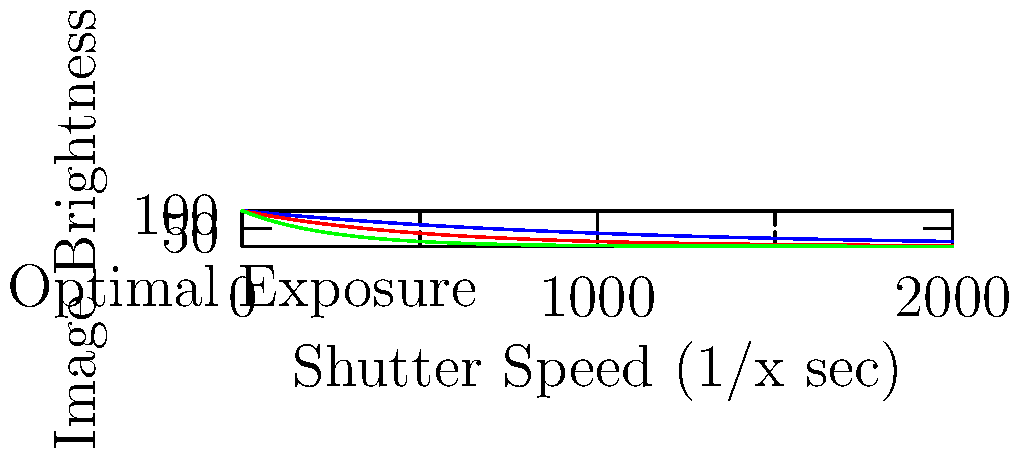You're shooting a dimly lit indoor basketball game. Given the graph showing the relationship between shutter speed and image brightness for different ISO settings, which combination of settings would you choose to achieve optimal exposure while minimizing motion blur?

A) 1/500 sec, ISO 1600
B) 1/1000 sec, ISO 3200
C) 1/2000 sec, ISO 6400
D) 1/250 sec, ISO 1600 To determine the best camera settings for a dimly lit indoor sports event, we need to consider three factors: shutter speed, ISO, and image brightness.

1. Shutter Speed: For sports photography, a fast shutter speed is crucial to freeze motion and avoid blur. Generally, 1/500 sec or faster is recommended for basketball.

2. ISO: Higher ISO allows for faster shutter speeds in low light but introduces more noise. We want to use the lowest ISO possible while maintaining a fast enough shutter speed.

3. Image Brightness: We aim for optimal exposure, which is represented by the horizontal line at the bottom of the graph.

Analyzing the options:

A) 1/500 sec, ISO 1600: Too dark, below optimal exposure.
B) 1/1000 sec, ISO 3200: Close to optimal exposure, fast enough for most action.
C) 1/2000 sec, ISO 6400: At optimal exposure, but unnecessarily high ISO might introduce more noise.
D) 1/250 sec, ISO 1600: Too slow for fast-moving sports, likely to result in motion blur.

Option B (1/1000 sec, ISO 3200) provides the best balance. It's fast enough to freeze most action, uses a lower ISO than option C to minimize noise, and achieves near-optimal exposure.
Answer: B) 1/1000 sec, ISO 3200 